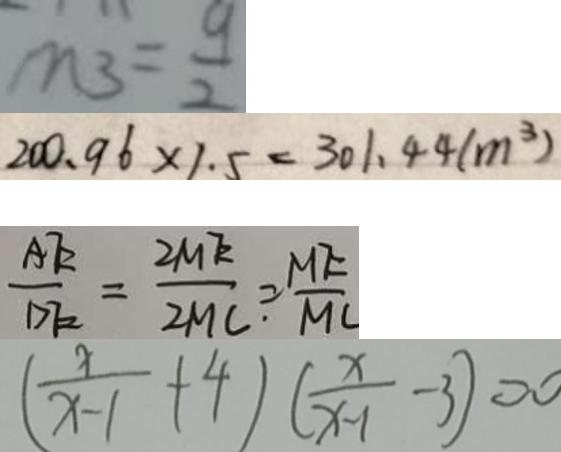Convert formula to latex. <formula><loc_0><loc_0><loc_500><loc_500>m _ { 3 } = \frac { 9 } { 2 } 
 2 0 0 . 9 6 \times 1 . 5 = 3 0 1 . 4 4 ( m ^ { 3 } ) 
 \frac { A E } { D E } = \frac { 2 M E } { 2 M C \cdot } = \frac { M E } { M C } 
 ( \frac { x } { x - 1 } + 4 ) ( \frac { x } { x - 1 } - 3 ) = 0</formula> 